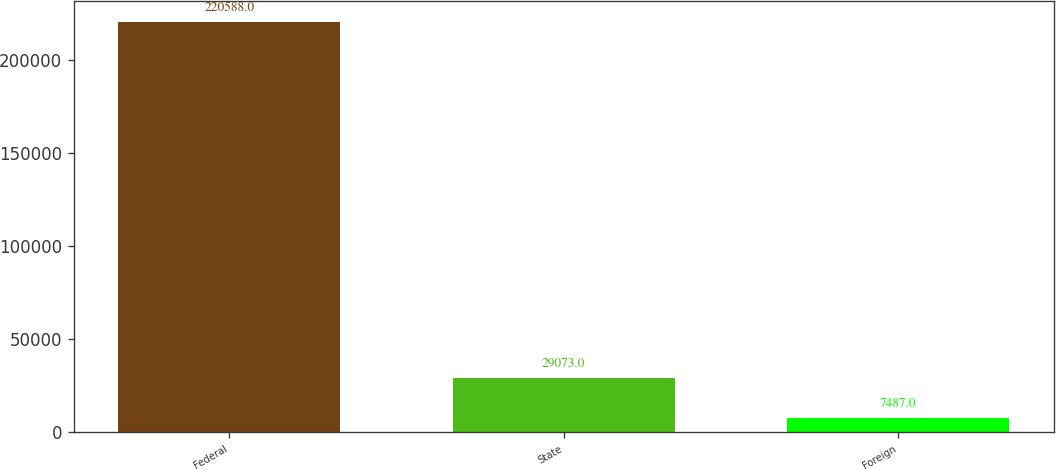Convert chart to OTSL. <chart><loc_0><loc_0><loc_500><loc_500><bar_chart><fcel>Federal<fcel>State<fcel>Foreign<nl><fcel>220588<fcel>29073<fcel>7487<nl></chart> 